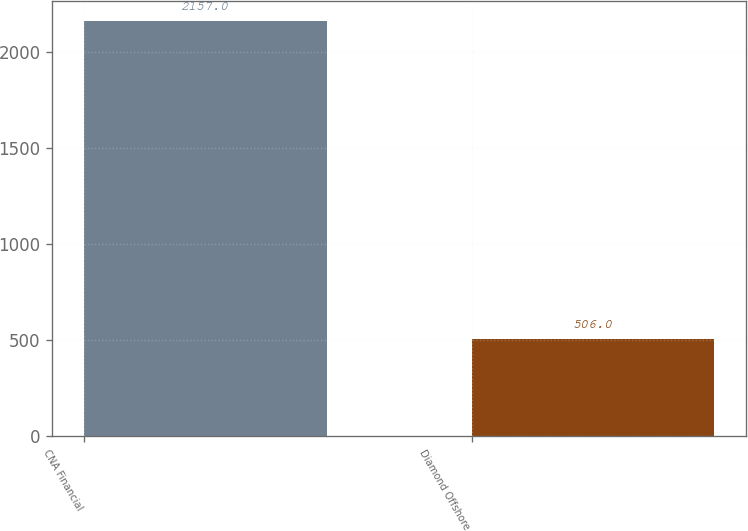<chart> <loc_0><loc_0><loc_500><loc_500><bar_chart><fcel>CNA Financial<fcel>Diamond Offshore<nl><fcel>2157<fcel>506<nl></chart> 